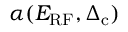<formula> <loc_0><loc_0><loc_500><loc_500>\alpha ( E _ { R F } , \Delta _ { c } )</formula> 